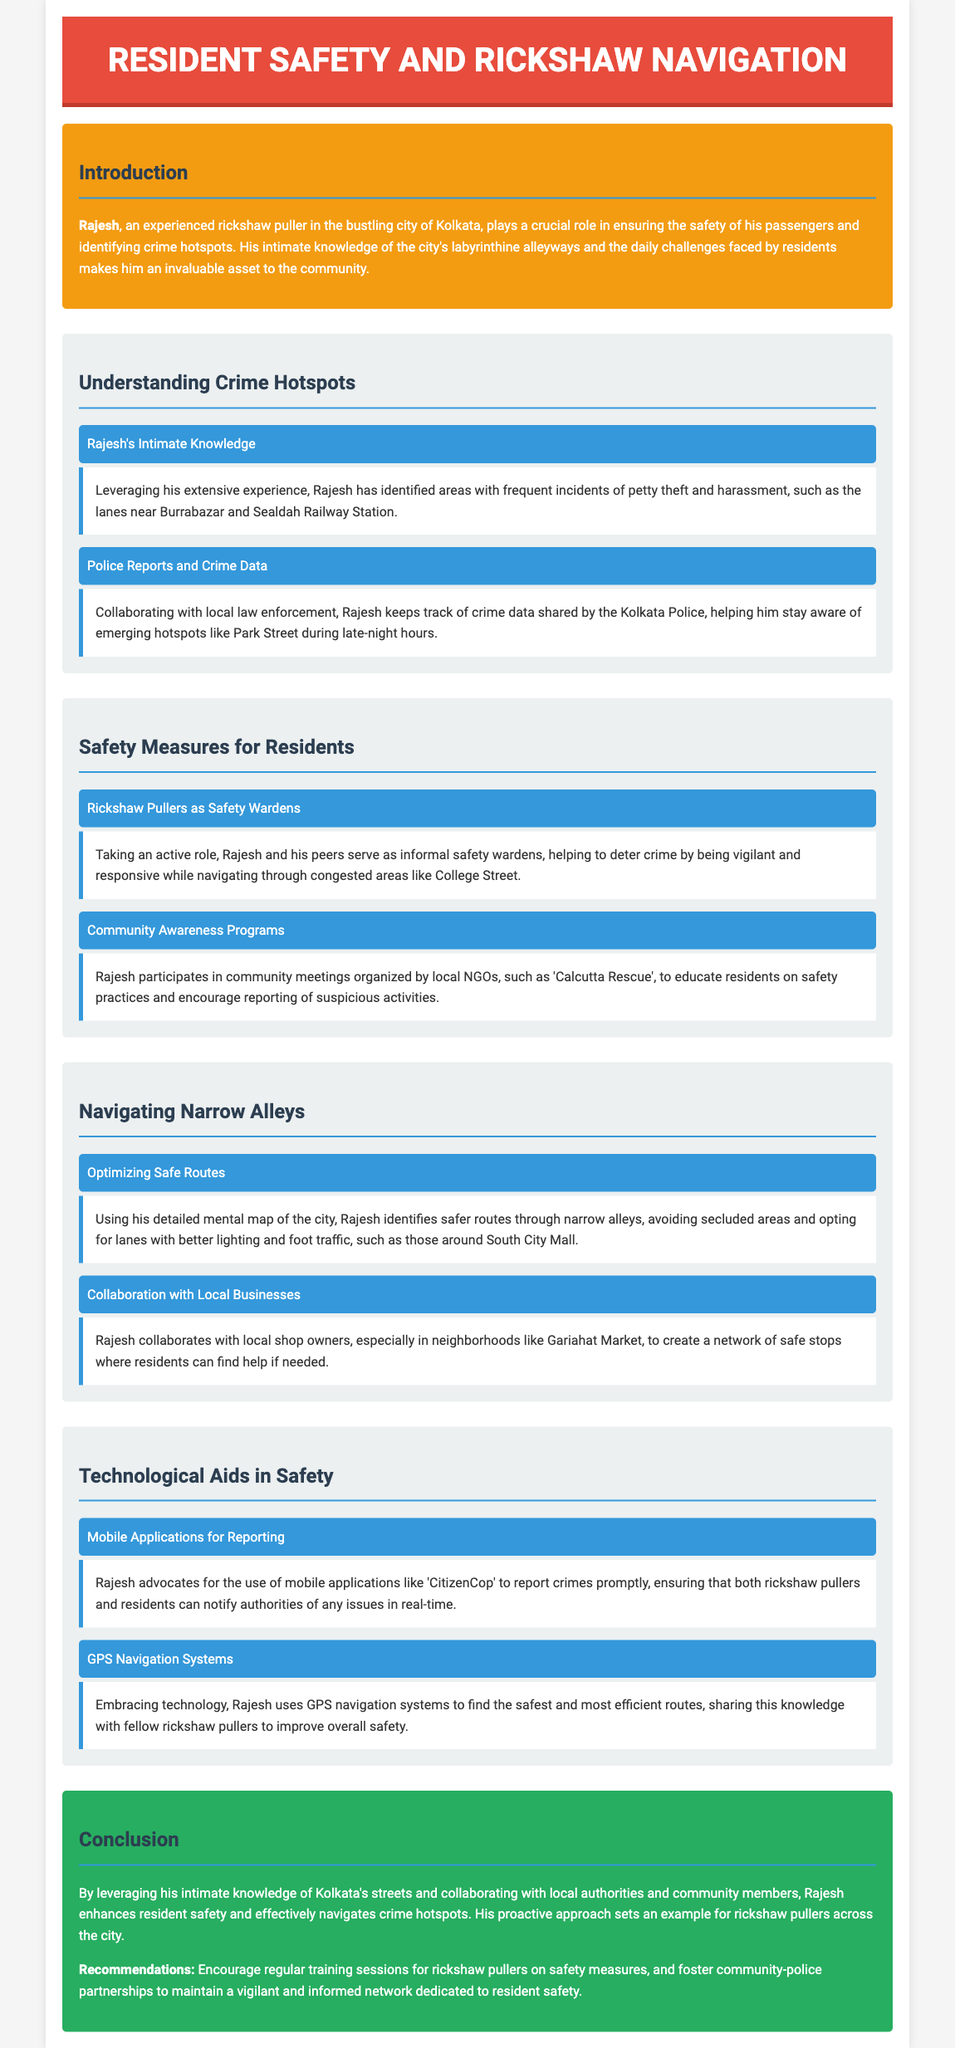What is Rajesh's profession? The document introduces Rajesh as an experienced rickshaw puller in Kolkata.
Answer: rickshaw puller Which area has frequent incidents of petty theft? The document mentions that frequent incidents occur in the lanes near Burrabazar and Sealdah Railway Station.
Answer: Burrabazar and Sealdah Railway Station What role do rickshaw pullers like Rajesh serve in the community? The document states that Rajesh and his peers serve as informal safety wardens.
Answer: safety wardens What mobile application does Rajesh advocate for crime reporting? The document notes that Rajesh advocates for the use of the 'CitizenCop' mobile application.
Answer: CitizenCop Which neighborhood do rickshaw pullers collaborate with local businesses? The section mentions collaboration with local shop owners in neighborhoods like Gariahat Market.
Answer: Gariahat Market What is a technological aid mentioned that Rajesh uses for navigation? The document specifies that Rajesh uses GPS navigation systems for finding routes.
Answer: GPS navigation systems What type of programs does Rajesh participate in? The document lists community awareness programs organized by local NGOs.
Answer: community awareness programs What should be encouraged for rickshaw pullers according to the conclusion? The conclusion recommends regular training sessions for rickshaw pullers on safety measures.
Answer: regular training sessions How does Rajesh enhance resident safety? The document states that Rajesh enhances safety by collaborating with local authorities and community members.
Answer: collaborating with local authorities and community members 